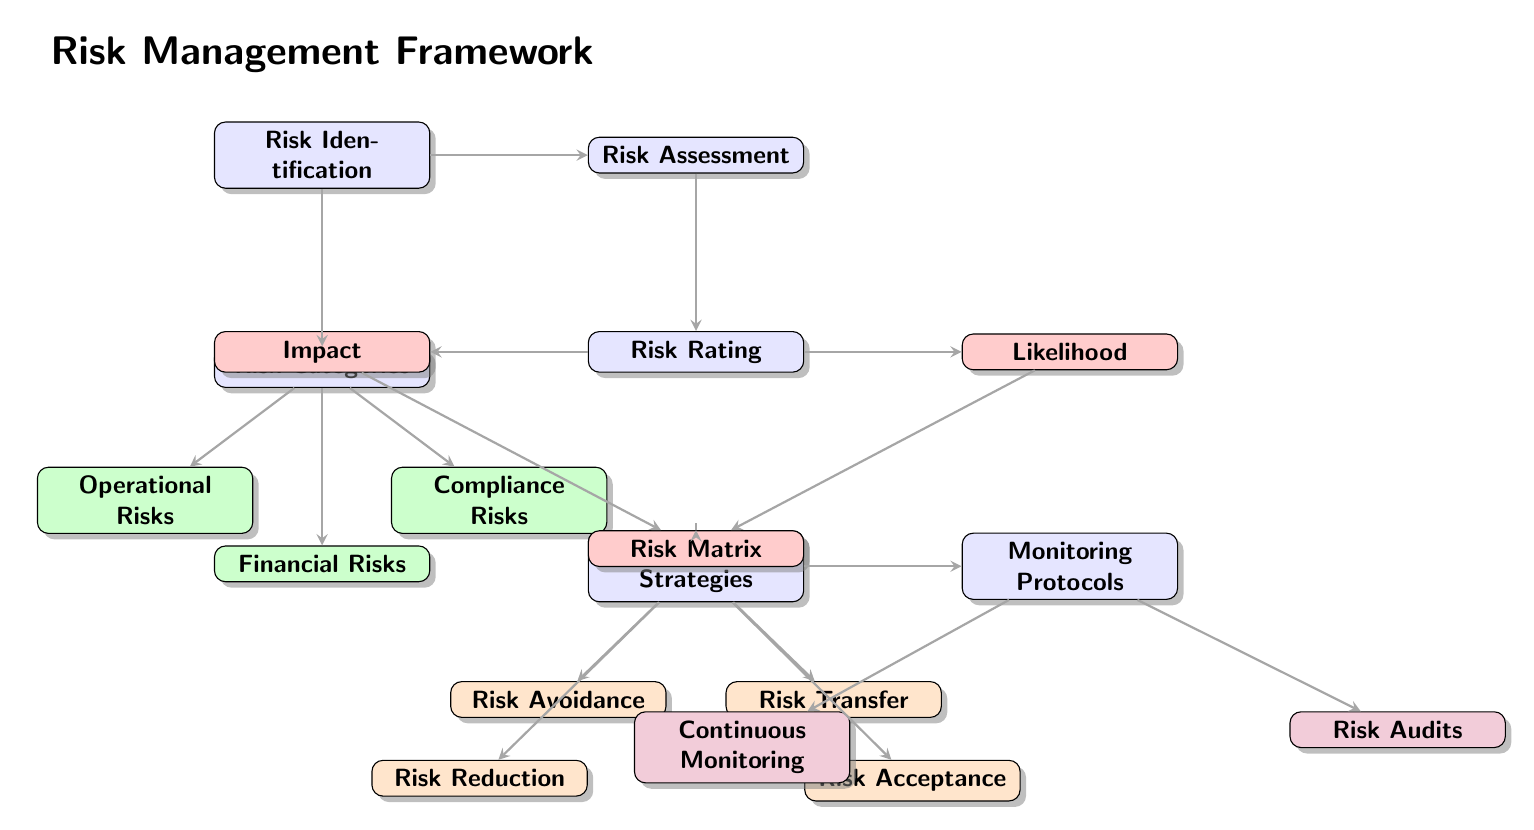What is the title of the diagram? The title is located at the top of the diagram and provides a brief description of what the framework represents. It clearly states "Risk Management Framework" above the central node of risk identification.
Answer: Risk Management Framework How many risk categories are displayed in the diagram? To determine the number of risk categories, count the nodes that fall under "Risk Categories". There are three categories listed: Operational Risks, Financial Risks, and Compliance Risks.
Answer: 3 What connects Risk Identification to Risk Assessment? The connection from Risk Identification to Risk Assessment is represented by a directed edge, indicating that Risk Identification informs or leads to Risk Assessment.
Answer: Directed edge Which risk mitigation strategy directly corresponds to Risk Reduction? Risk Reduction is located as a sub-node of Mitigation Strategies, indicating it is one of the methods used to mitigate risks identified in the framework. The direct path from mitigation strategies to Risk Reduction confirms this relationship.
Answer: Risk Reduction What are the two components of Risk Rating? The two components, or sub-nodes, under Risk Rating provide the criteria for evaluating risks. They are Impact and Likelihood, which are positioned to the left and right, respectively, of the Risk Rating node.
Answer: Impact, Likelihood Which nodes are categorized under Monitoring Protocols? Monitoring Protocols has two specific sub-nodes connected to it: Continuous Monitoring and Risk Audits. These represent different approaches to monitoring risks after strategies have been implemented.
Answer: Continuous Monitoring, Risk Audits Explain the flow from Risk Assessment to Mitigation Strategies. The flow starts at Risk Assessment, which is connected by a directed edge to Risk Rating. From Risk Rating, there is a path towards Mitigation Strategies, indicating that the assessment outcome informs the strategies for mitigating identified risks. Therefore, the assessment directly influences which mitigation strategy is selected.
Answer: Directed flow How many total nodes are there in the diagram? To find the total nodes, count all main categories, sub-nodes, and any additional nodes displayed within the diagram. The total includes: Risk Identification, Risk Assessment, Risk Categories, Risk Rating, Mitigation Strategies, and Monitoring Protocols, along with all sub-nodes. The final count reveals there are 12 nodes total.
Answer: 12 Which type of risk mitigation strategy is not focused on avoidance? The strategy that does not focus on avoidance needs to be identified from the sub-nodes of Mitigation Strategies. The strategies listed include Risk Acceptance, Risk Reduction, and Risk Transfer, implying that Risk Acceptance is the only one that does not focus on avoiding risks.
Answer: Risk Acceptance 